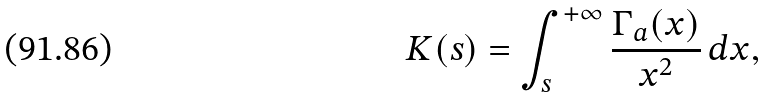<formula> <loc_0><loc_0><loc_500><loc_500>K ( s ) = \int _ { s } ^ { + \infty } \frac { \Gamma _ { a } ( x ) } { x ^ { 2 } } \, d x ,</formula> 